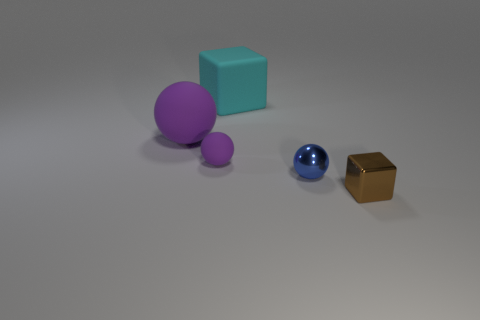How many matte things are the same color as the tiny rubber sphere?
Offer a terse response. 1. There is a large object that is the same color as the small rubber sphere; what is its shape?
Make the answer very short. Sphere. What is the size of the other sphere that is the same color as the large sphere?
Keep it short and to the point. Small. How many large blocks are behind the small brown metallic cube?
Provide a short and direct response. 1. What is the size of the block right of the shiny thing behind the metal thing that is on the right side of the blue shiny ball?
Offer a very short reply. Small. There is a small shiny thing to the left of the metallic thing to the right of the blue ball; is there a small blue ball that is behind it?
Give a very brief answer. No. Is the number of big brown matte cubes greater than the number of big balls?
Offer a terse response. No. There is a large matte thing in front of the cyan cube; what is its color?
Keep it short and to the point. Purple. Is the number of tiny purple rubber spheres that are behind the blue sphere greater than the number of large purple rubber balls?
Ensure brevity in your answer.  No. Does the small cube have the same material as the small purple ball?
Your response must be concise. No. 